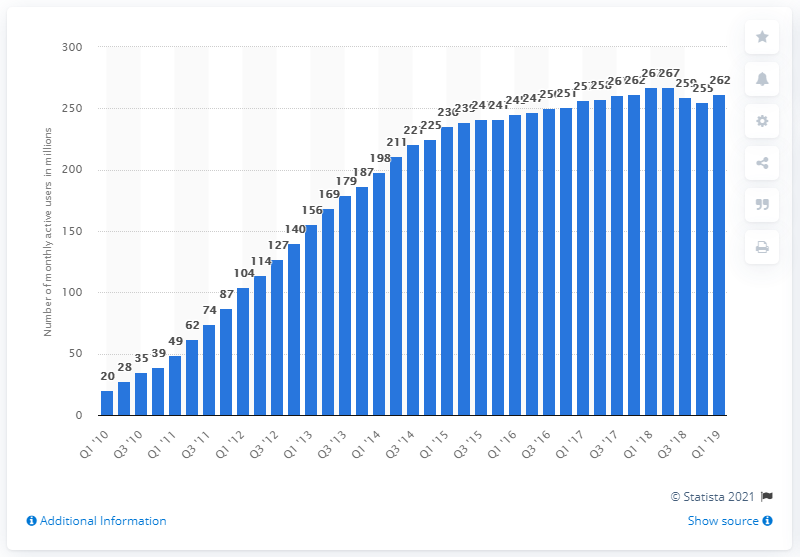Identify some key points in this picture. According to the first quarter of 2019, there were approximately 262 international Twitter users. 